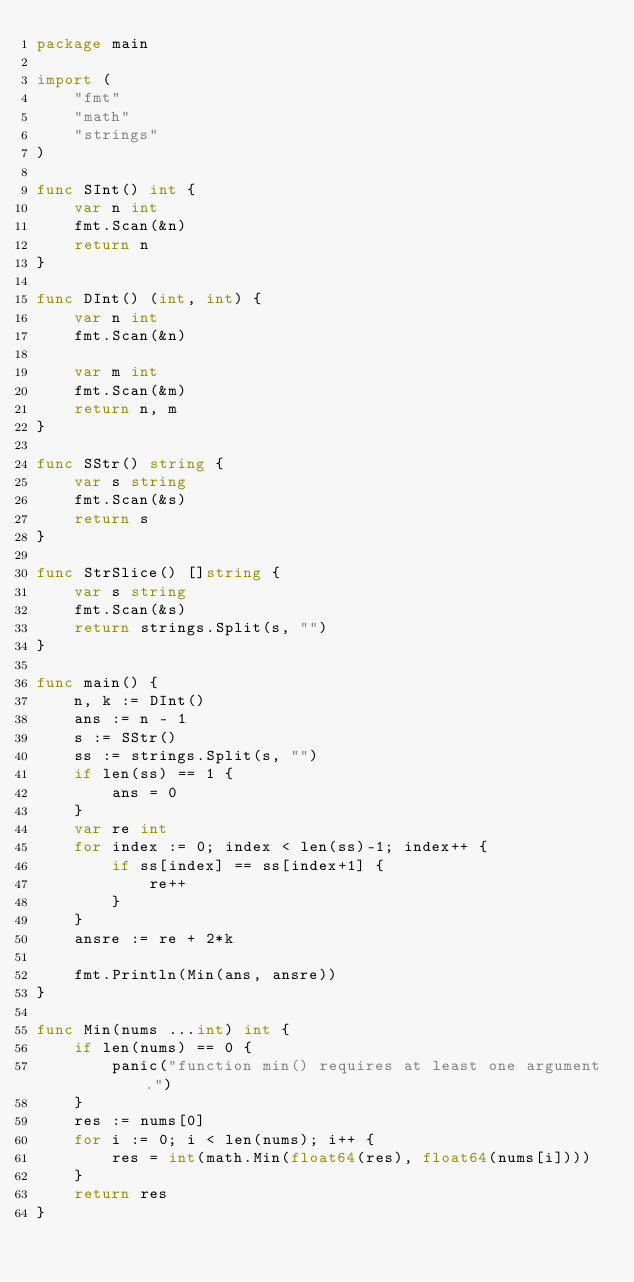Convert code to text. <code><loc_0><loc_0><loc_500><loc_500><_Go_>package main

import (
	"fmt"
	"math"
	"strings"
)

func SInt() int {
	var n int
	fmt.Scan(&n)
	return n
}

func DInt() (int, int) {
	var n int
	fmt.Scan(&n)

	var m int
	fmt.Scan(&m)
	return n, m
}

func SStr() string {
	var s string
	fmt.Scan(&s)
	return s
}

func StrSlice() []string {
	var s string
	fmt.Scan(&s)
	return strings.Split(s, "")
}

func main() {
	n, k := DInt()
	ans := n - 1
	s := SStr()
	ss := strings.Split(s, "")
	if len(ss) == 1 {
		ans = 0
	}
	var re int
	for index := 0; index < len(ss)-1; index++ {
		if ss[index] == ss[index+1] {
			re++
		}
	}
	ansre := re + 2*k

	fmt.Println(Min(ans, ansre))
}

func Min(nums ...int) int {
	if len(nums) == 0 {
		panic("function min() requires at least one argument.")
	}
	res := nums[0]
	for i := 0; i < len(nums); i++ {
		res = int(math.Min(float64(res), float64(nums[i])))
	}
	return res
}
</code> 